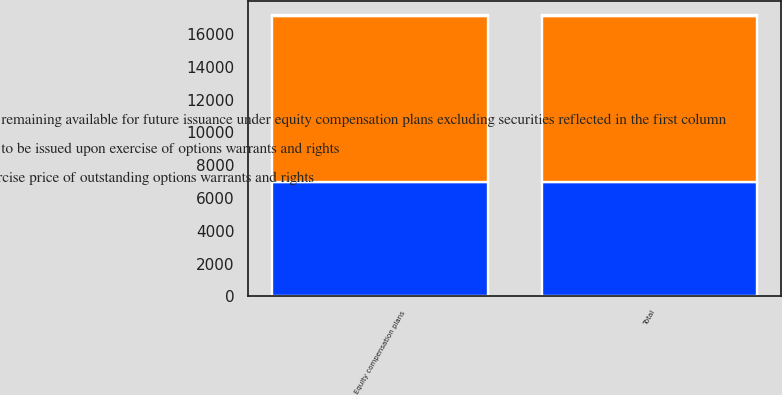Convert chart to OTSL. <chart><loc_0><loc_0><loc_500><loc_500><stacked_bar_chart><ecel><fcel>Equity compensation plans<fcel>Total<nl><fcel>Number of securities remaining available for future issuance under equity compensation plans excluding securities reflected in the first column<fcel>6950<fcel>6950<nl><fcel>Weightedaverage exercise price of outstanding options warrants and rights<fcel>18.15<fcel>18.15<nl><fcel>Number of securities to be issued upon exercise of options warrants and rights<fcel>10169<fcel>10169<nl></chart> 